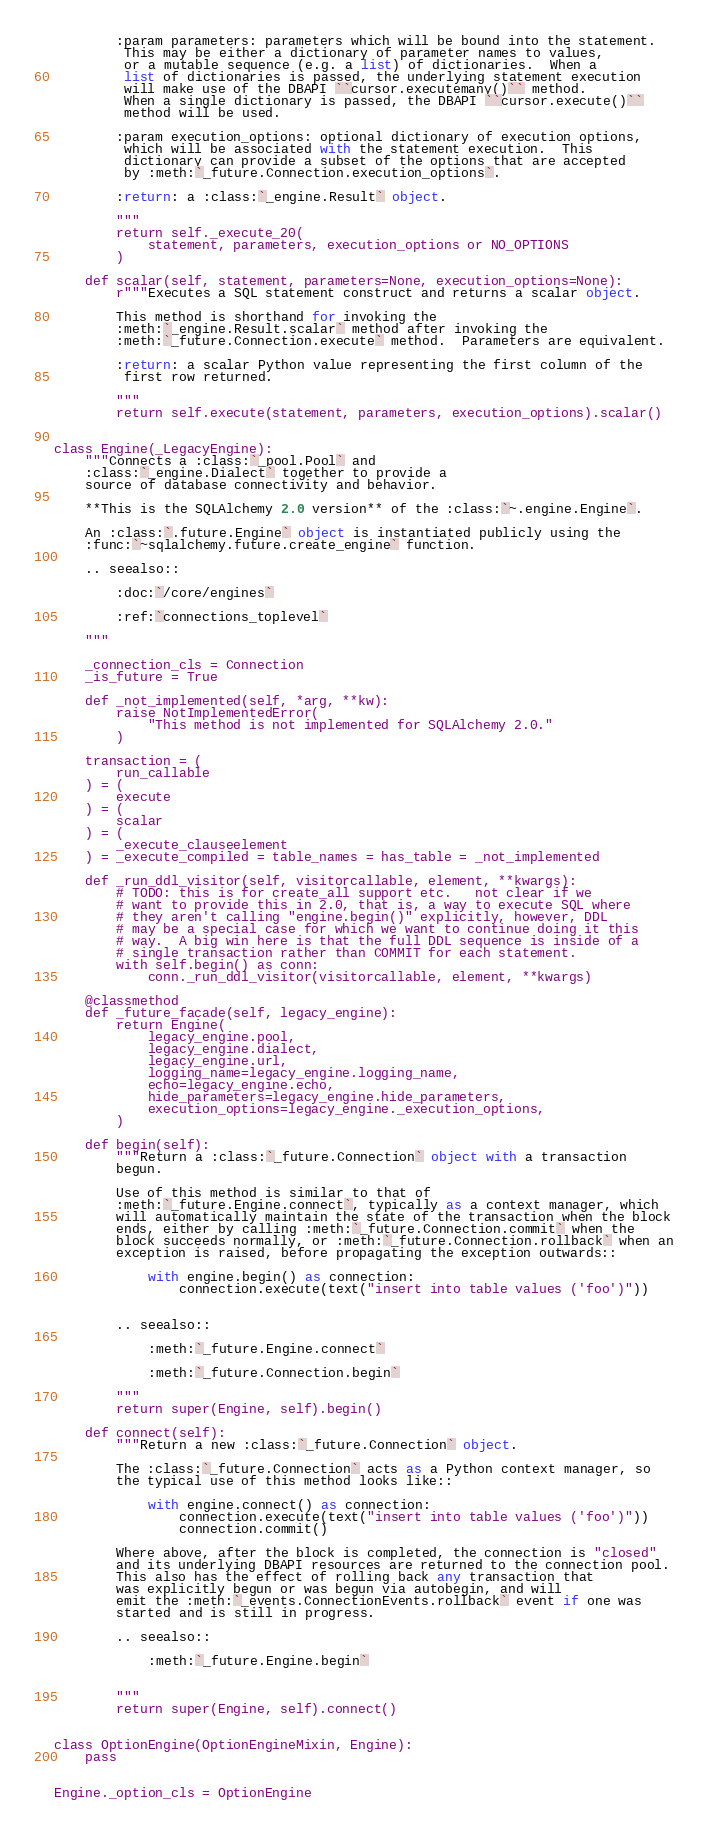<code> <loc_0><loc_0><loc_500><loc_500><_Python_>
        :param parameters: parameters which will be bound into the statement.
         This may be either a dictionary of parameter names to values,
         or a mutable sequence (e.g. a list) of dictionaries.  When a
         list of dictionaries is passed, the underlying statement execution
         will make use of the DBAPI ``cursor.executemany()`` method.
         When a single dictionary is passed, the DBAPI ``cursor.execute()``
         method will be used.

        :param execution_options: optional dictionary of execution options,
         which will be associated with the statement execution.  This
         dictionary can provide a subset of the options that are accepted
         by :meth:`_future.Connection.execution_options`.

        :return: a :class:`_engine.Result` object.

        """
        return self._execute_20(
            statement, parameters, execution_options or NO_OPTIONS
        )

    def scalar(self, statement, parameters=None, execution_options=None):
        r"""Executes a SQL statement construct and returns a scalar object.

        This method is shorthand for invoking the
        :meth:`_engine.Result.scalar` method after invoking the
        :meth:`_future.Connection.execute` method.  Parameters are equivalent.

        :return: a scalar Python value representing the first column of the
         first row returned.

        """
        return self.execute(statement, parameters, execution_options).scalar()


class Engine(_LegacyEngine):
    """Connects a :class:`_pool.Pool` and
    :class:`_engine.Dialect` together to provide a
    source of database connectivity and behavior.

    **This is the SQLAlchemy 2.0 version** of the :class:`~.engine.Engine`.

    An :class:`.future.Engine` object is instantiated publicly using the
    :func:`~sqlalchemy.future.create_engine` function.

    .. seealso::

        :doc:`/core/engines`

        :ref:`connections_toplevel`

    """

    _connection_cls = Connection
    _is_future = True

    def _not_implemented(self, *arg, **kw):
        raise NotImplementedError(
            "This method is not implemented for SQLAlchemy 2.0."
        )

    transaction = (
        run_callable
    ) = (
        execute
    ) = (
        scalar
    ) = (
        _execute_clauseelement
    ) = _execute_compiled = table_names = has_table = _not_implemented

    def _run_ddl_visitor(self, visitorcallable, element, **kwargs):
        # TODO: this is for create_all support etc.   not clear if we
        # want to provide this in 2.0, that is, a way to execute SQL where
        # they aren't calling "engine.begin()" explicitly, however, DDL
        # may be a special case for which we want to continue doing it this
        # way.  A big win here is that the full DDL sequence is inside of a
        # single transaction rather than COMMIT for each statement.
        with self.begin() as conn:
            conn._run_ddl_visitor(visitorcallable, element, **kwargs)

    @classmethod
    def _future_facade(self, legacy_engine):
        return Engine(
            legacy_engine.pool,
            legacy_engine.dialect,
            legacy_engine.url,
            logging_name=legacy_engine.logging_name,
            echo=legacy_engine.echo,
            hide_parameters=legacy_engine.hide_parameters,
            execution_options=legacy_engine._execution_options,
        )

    def begin(self):
        """Return a :class:`_future.Connection` object with a transaction
        begun.

        Use of this method is similar to that of
        :meth:`_future.Engine.connect`, typically as a context manager, which
        will automatically maintain the state of the transaction when the block
        ends, either by calling :meth:`_future.Connection.commit` when the
        block succeeds normally, or :meth:`_future.Connection.rollback` when an
        exception is raised, before propagating the exception outwards::

            with engine.begin() as connection:
                connection.execute(text("insert into table values ('foo')"))


        .. seealso::

            :meth:`_future.Engine.connect`

            :meth:`_future.Connection.begin`

        """
        return super(Engine, self).begin()

    def connect(self):
        """Return a new :class:`_future.Connection` object.

        The :class:`_future.Connection` acts as a Python context manager, so
        the typical use of this method looks like::

            with engine.connect() as connection:
                connection.execute(text("insert into table values ('foo')"))
                connection.commit()

        Where above, after the block is completed, the connection is "closed"
        and its underlying DBAPI resources are returned to the connection pool.
        This also has the effect of rolling back any transaction that
        was explicitly begun or was begun via autobegin, and will
        emit the :meth:`_events.ConnectionEvents.rollback` event if one was
        started and is still in progress.

        .. seealso::

            :meth:`_future.Engine.begin`


        """
        return super(Engine, self).connect()


class OptionEngine(OptionEngineMixin, Engine):
    pass


Engine._option_cls = OptionEngine
</code> 